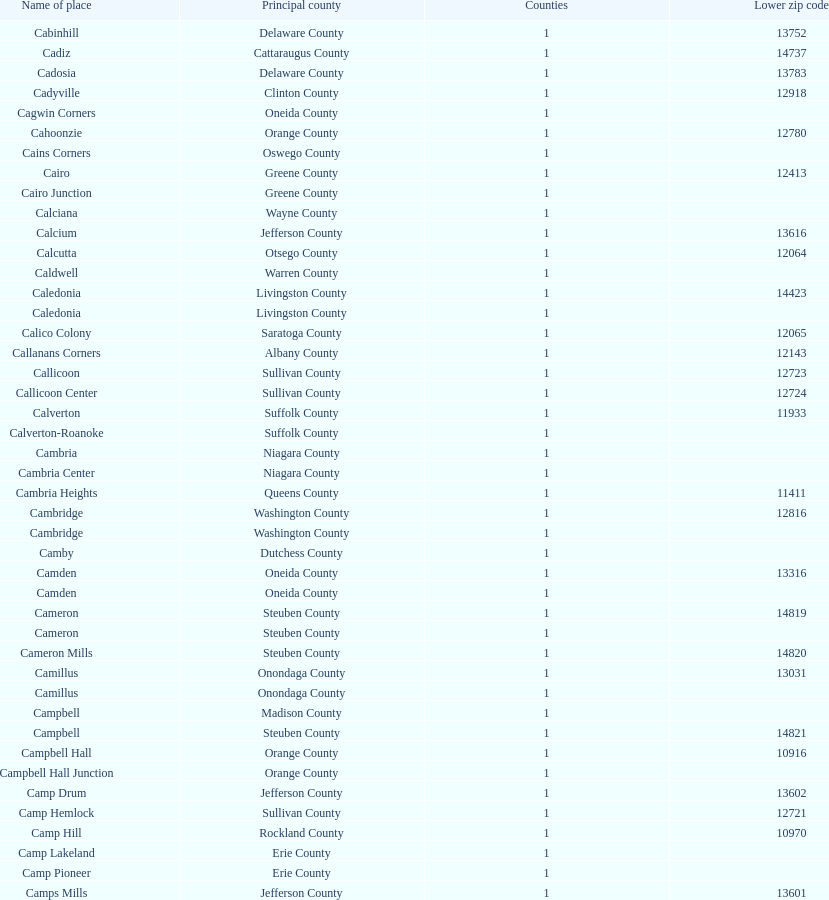Which county is listed above calciana? Cairo Junction. 